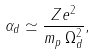Convert formula to latex. <formula><loc_0><loc_0><loc_500><loc_500>\alpha _ { d } \simeq \frac { Z e ^ { 2 } } { m _ { p } \, \Omega _ { d } ^ { 2 } } ,</formula> 